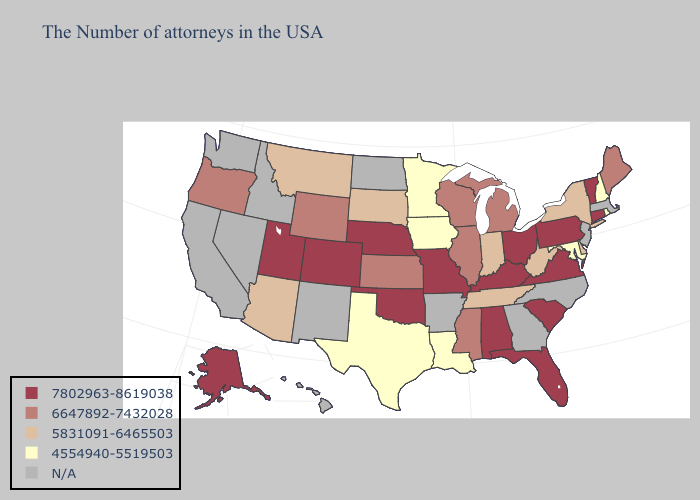Name the states that have a value in the range 6647892-7432028?
Short answer required. Maine, Michigan, Wisconsin, Illinois, Mississippi, Kansas, Wyoming, Oregon. Does Texas have the highest value in the South?
Give a very brief answer. No. Does the first symbol in the legend represent the smallest category?
Answer briefly. No. Does Utah have the highest value in the USA?
Answer briefly. Yes. How many symbols are there in the legend?
Be succinct. 5. Does New York have the highest value in the Northeast?
Answer briefly. No. What is the highest value in the MidWest ?
Concise answer only. 7802963-8619038. Name the states that have a value in the range N/A?
Write a very short answer. Massachusetts, New Jersey, North Carolina, Georgia, Arkansas, North Dakota, New Mexico, Idaho, Nevada, California, Washington, Hawaii. What is the lowest value in the Northeast?
Keep it brief. 4554940-5519503. Name the states that have a value in the range 7802963-8619038?
Keep it brief. Vermont, Connecticut, Pennsylvania, Virginia, South Carolina, Ohio, Florida, Kentucky, Alabama, Missouri, Nebraska, Oklahoma, Colorado, Utah, Alaska. How many symbols are there in the legend?
Keep it brief. 5. Which states have the lowest value in the West?
Give a very brief answer. Montana, Arizona. What is the lowest value in states that border Mississippi?
Write a very short answer. 4554940-5519503. What is the lowest value in the USA?
Quick response, please. 4554940-5519503. 